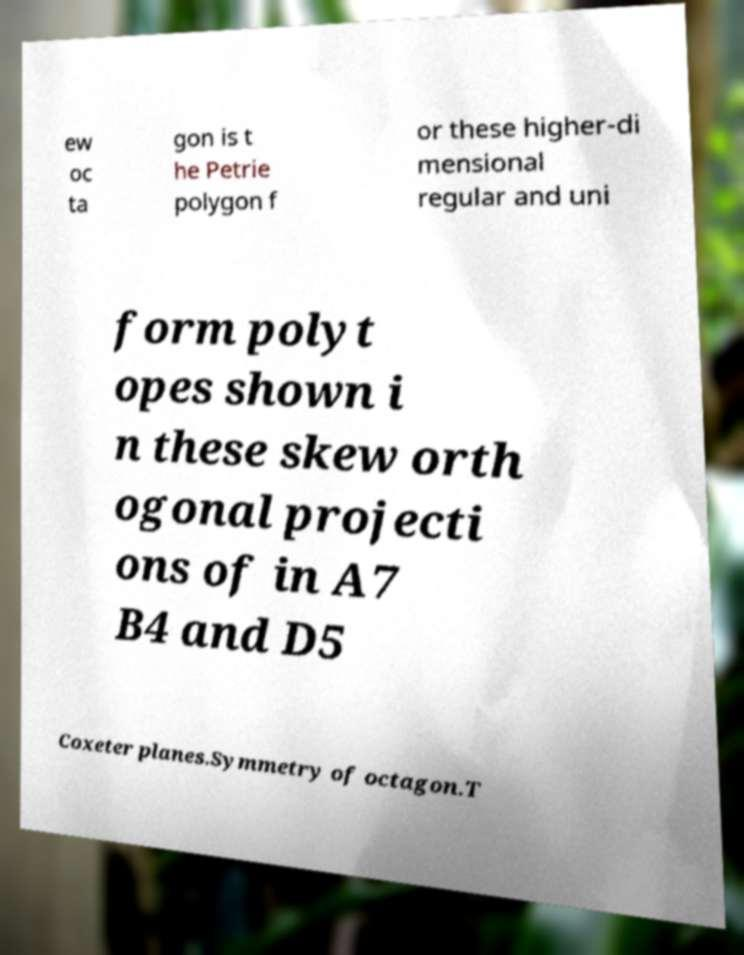There's text embedded in this image that I need extracted. Can you transcribe it verbatim? ew oc ta gon is t he Petrie polygon f or these higher-di mensional regular and uni form polyt opes shown i n these skew orth ogonal projecti ons of in A7 B4 and D5 Coxeter planes.Symmetry of octagon.T 